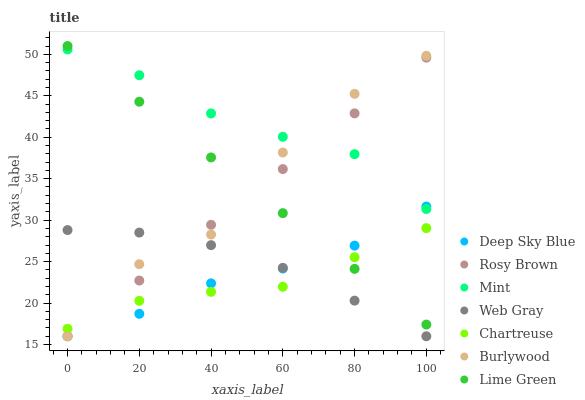Does Chartreuse have the minimum area under the curve?
Answer yes or no. Yes. Does Mint have the maximum area under the curve?
Answer yes or no. Yes. Does Burlywood have the minimum area under the curve?
Answer yes or no. No. Does Burlywood have the maximum area under the curve?
Answer yes or no. No. Is Lime Green the smoothest?
Answer yes or no. Yes. Is Burlywood the roughest?
Answer yes or no. Yes. Is Burlywood the smoothest?
Answer yes or no. No. Is Lime Green the roughest?
Answer yes or no. No. Does Web Gray have the lowest value?
Answer yes or no. Yes. Does Lime Green have the lowest value?
Answer yes or no. No. Does Lime Green have the highest value?
Answer yes or no. Yes. Does Burlywood have the highest value?
Answer yes or no. No. Is Web Gray less than Mint?
Answer yes or no. Yes. Is Lime Green greater than Web Gray?
Answer yes or no. Yes. Does Deep Sky Blue intersect Chartreuse?
Answer yes or no. Yes. Is Deep Sky Blue less than Chartreuse?
Answer yes or no. No. Is Deep Sky Blue greater than Chartreuse?
Answer yes or no. No. Does Web Gray intersect Mint?
Answer yes or no. No. 